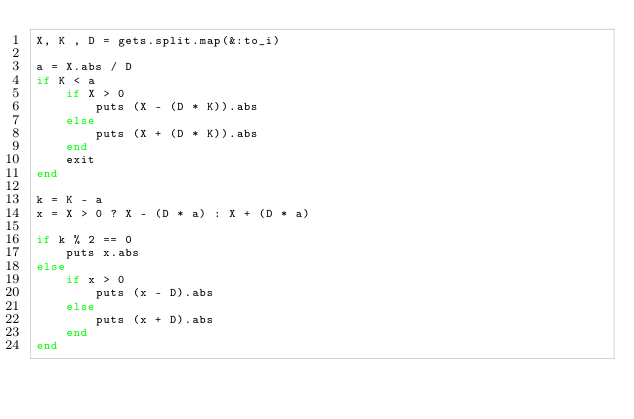<code> <loc_0><loc_0><loc_500><loc_500><_Ruby_>X, K , D = gets.split.map(&:to_i)

a = X.abs / D
if K < a
    if X > 0
        puts (X - (D * K)).abs
    else
        puts (X + (D * K)).abs
    end
    exit
end

k = K - a
x = X > 0 ? X - (D * a) : X + (D * a)

if k % 2 == 0
    puts x.abs
else
    if x > 0
        puts (x - D).abs
    else
        puts (x + D).abs
    end
end</code> 